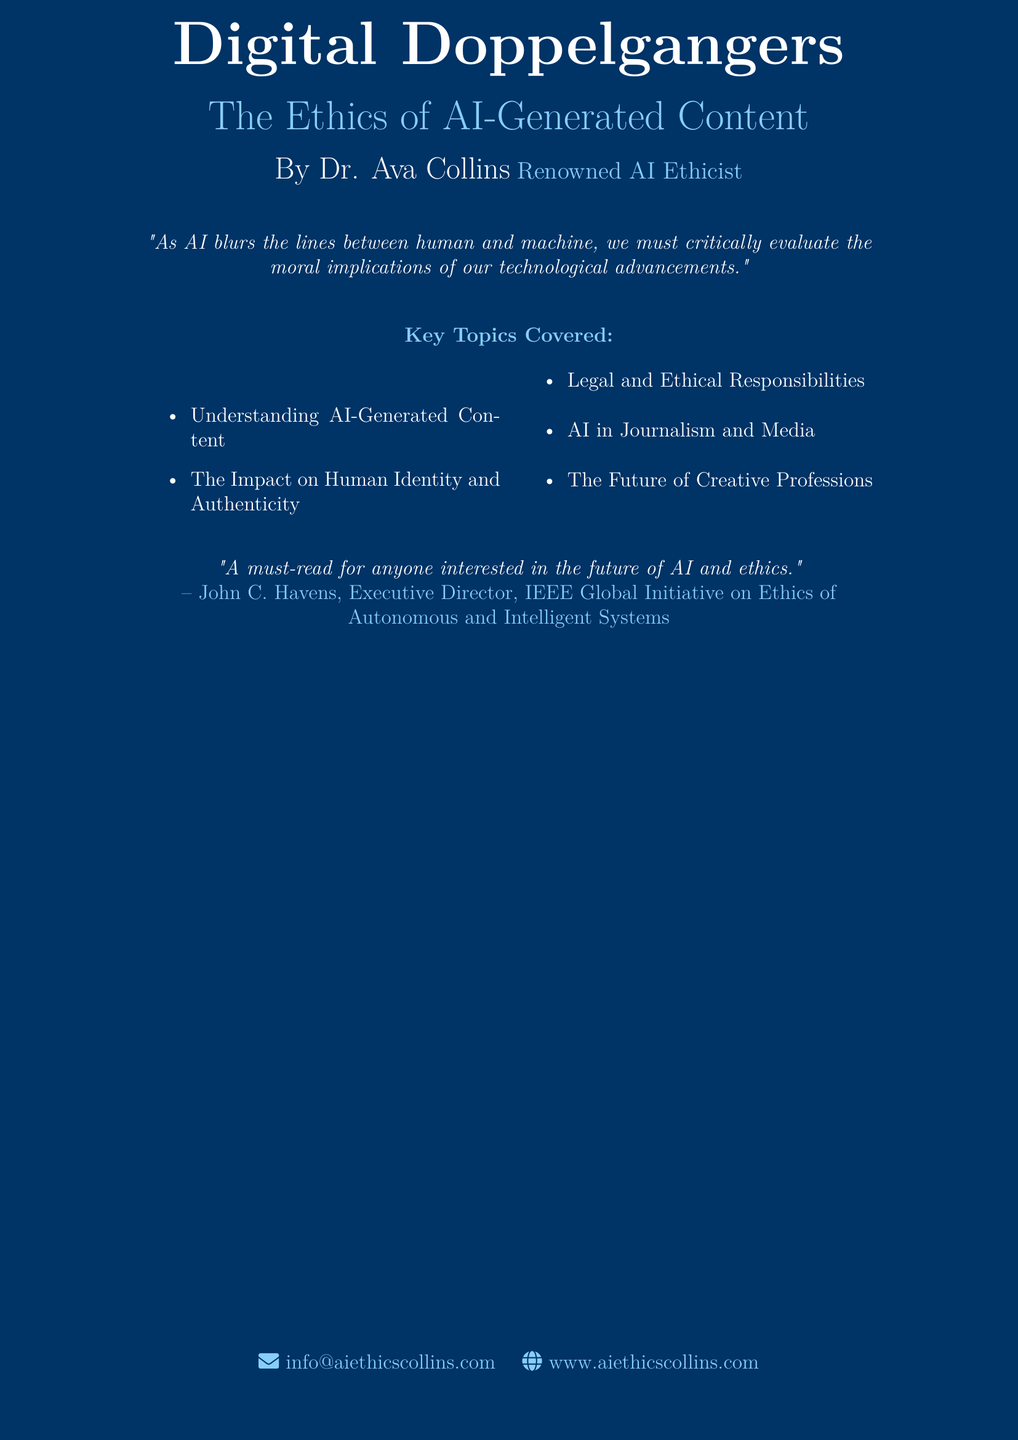What is the title of the book? The title can be found prominently on the cover of the document.
Answer: Digital Doppelgangers Who is the author of the book? The book cover lists the author’s name below the title.
Answer: Dr. Ava Collins What is Dr. Ava Collins’ profession? The book cover indicates her profession beneath her name.
Answer: Renowned AI Ethicist What is one key topic covered in the book? The book cover lists multiple key topics.
Answer: Understanding AI-Generated Content Who provided a testimonial for the book? The cover features a testimonial section with the name of the individual.
Answer: John C. Havens What does the testimonial describe the book as? The testimonial on the cover provides an opinion about the book.
Answer: A must-read How many key topics are listed on the cover? Counting the bullet points under the key topics section reveals the number.
Answer: Five What color is the background of the book cover? The document specifies the page color at the beginning.
Answer: Deep blue What type of publication is this document? The structure and content indicate its purpose.
Answer: Book cover 